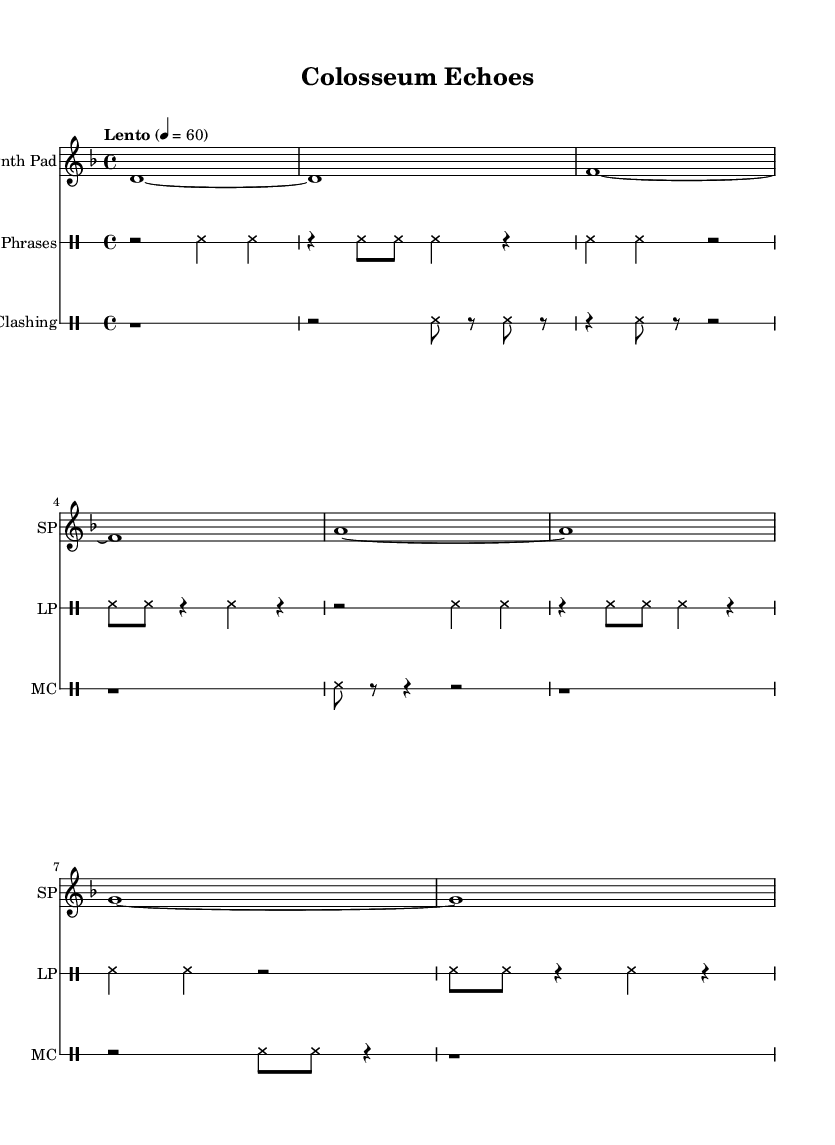What is the key signature of this music? The key signature is D minor, indicating that there is one flat (B♭) and the tonic of the piece is D.
Answer: D minor What is the time signature of this music? The time signature is 4/4, which is indicated by the notation at the beginning and suggests that there are four beats in each measure.
Answer: 4/4 What is the tempo marking for this piece? The tempo marking is "Lento", which means slowly, and it corresponds to a metronome marking of 60 beats per minute.
Answer: Lento How many different instrumental parts are in the score? There are three different instrumental parts: Synth Pad, Latin Phrases, and Metal Clashing, as indicated by the separate staffs in the score layout.
Answer: Three What type of music is this piece categorized as? This piece is categorized as Experimental music, evidenced by its use of ambient sounds and unconventional compositions, such as whispered phrases and clashing percussion.
Answer: Experimental What does the "cresc" and "dim" text indicate in this score? The terms "cresc" and "dim" indicate dynamic changes, specifically a crescendo (gradually getting louder) and a diminuendo (gradually getting softer), which are essential for the expressive nature of this experimental piece.
Answer: Crescendo and diminuendo 